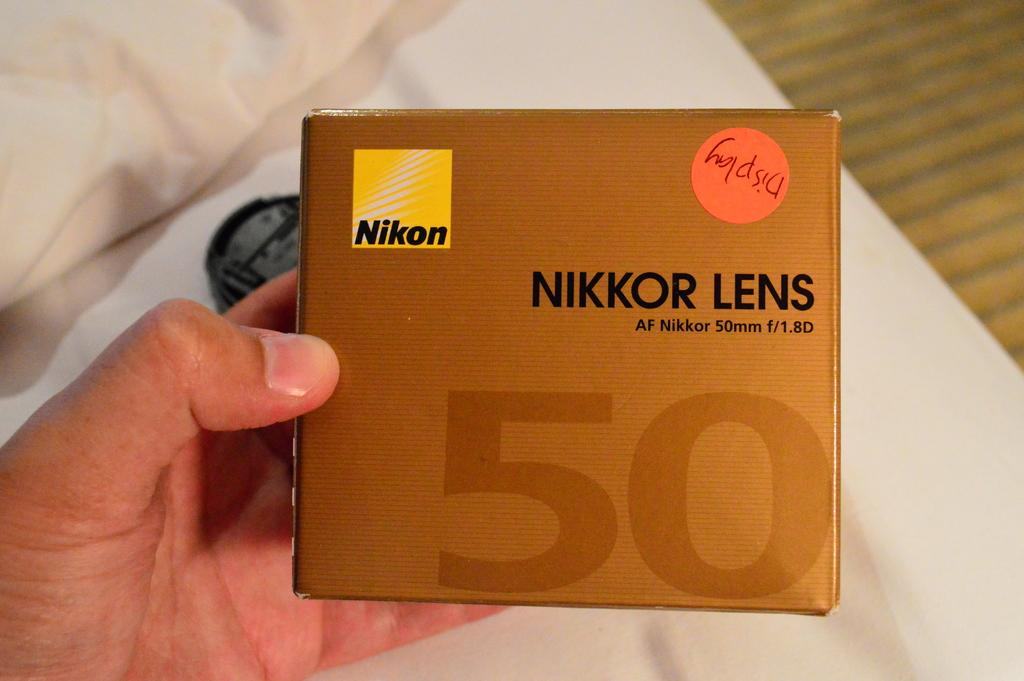Provide a one-sentence caption for the provided image. A person is holding a camera lens for a Nikkor 50MM. 